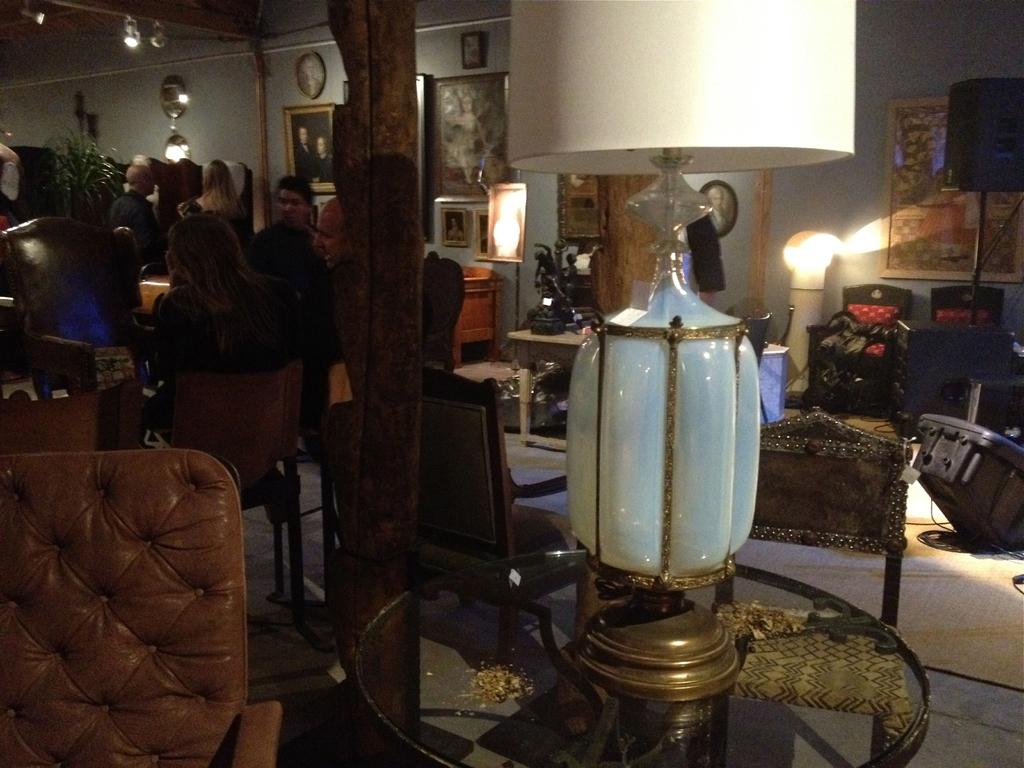What can be seen on the left side of the image? There are people sitting on chairs on the left side of the image. What is located in the middle of the image? There is a glass bulb on a table in the middle of the image. What is on the right side of the image? There are photo frames on a wall on the right side of the image. What is the texture of the people's legs in the image? There is no information about the texture of the people's legs in the image, as the focus is on their sitting position and the presence of chairs. 